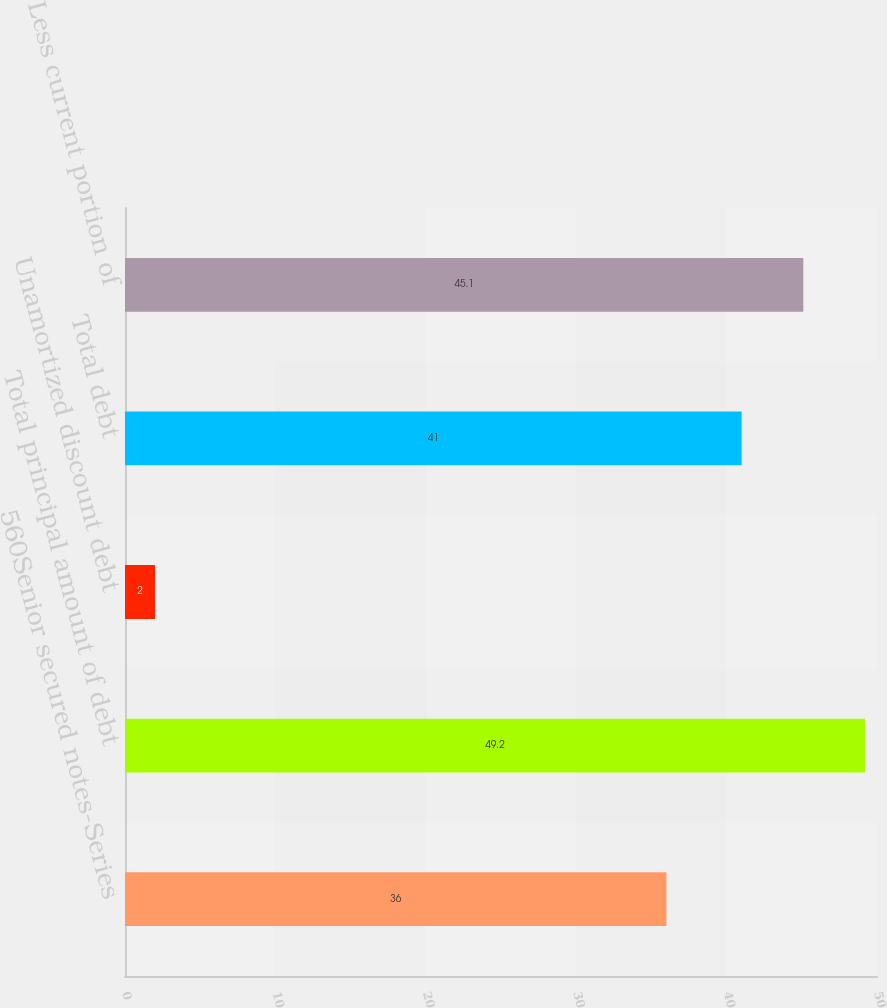<chart> <loc_0><loc_0><loc_500><loc_500><bar_chart><fcel>560Senior secured notes-Series<fcel>Total principal amount of debt<fcel>Unamortized discount debt<fcel>Total debt<fcel>Less current portion of<nl><fcel>36<fcel>49.2<fcel>2<fcel>41<fcel>45.1<nl></chart> 